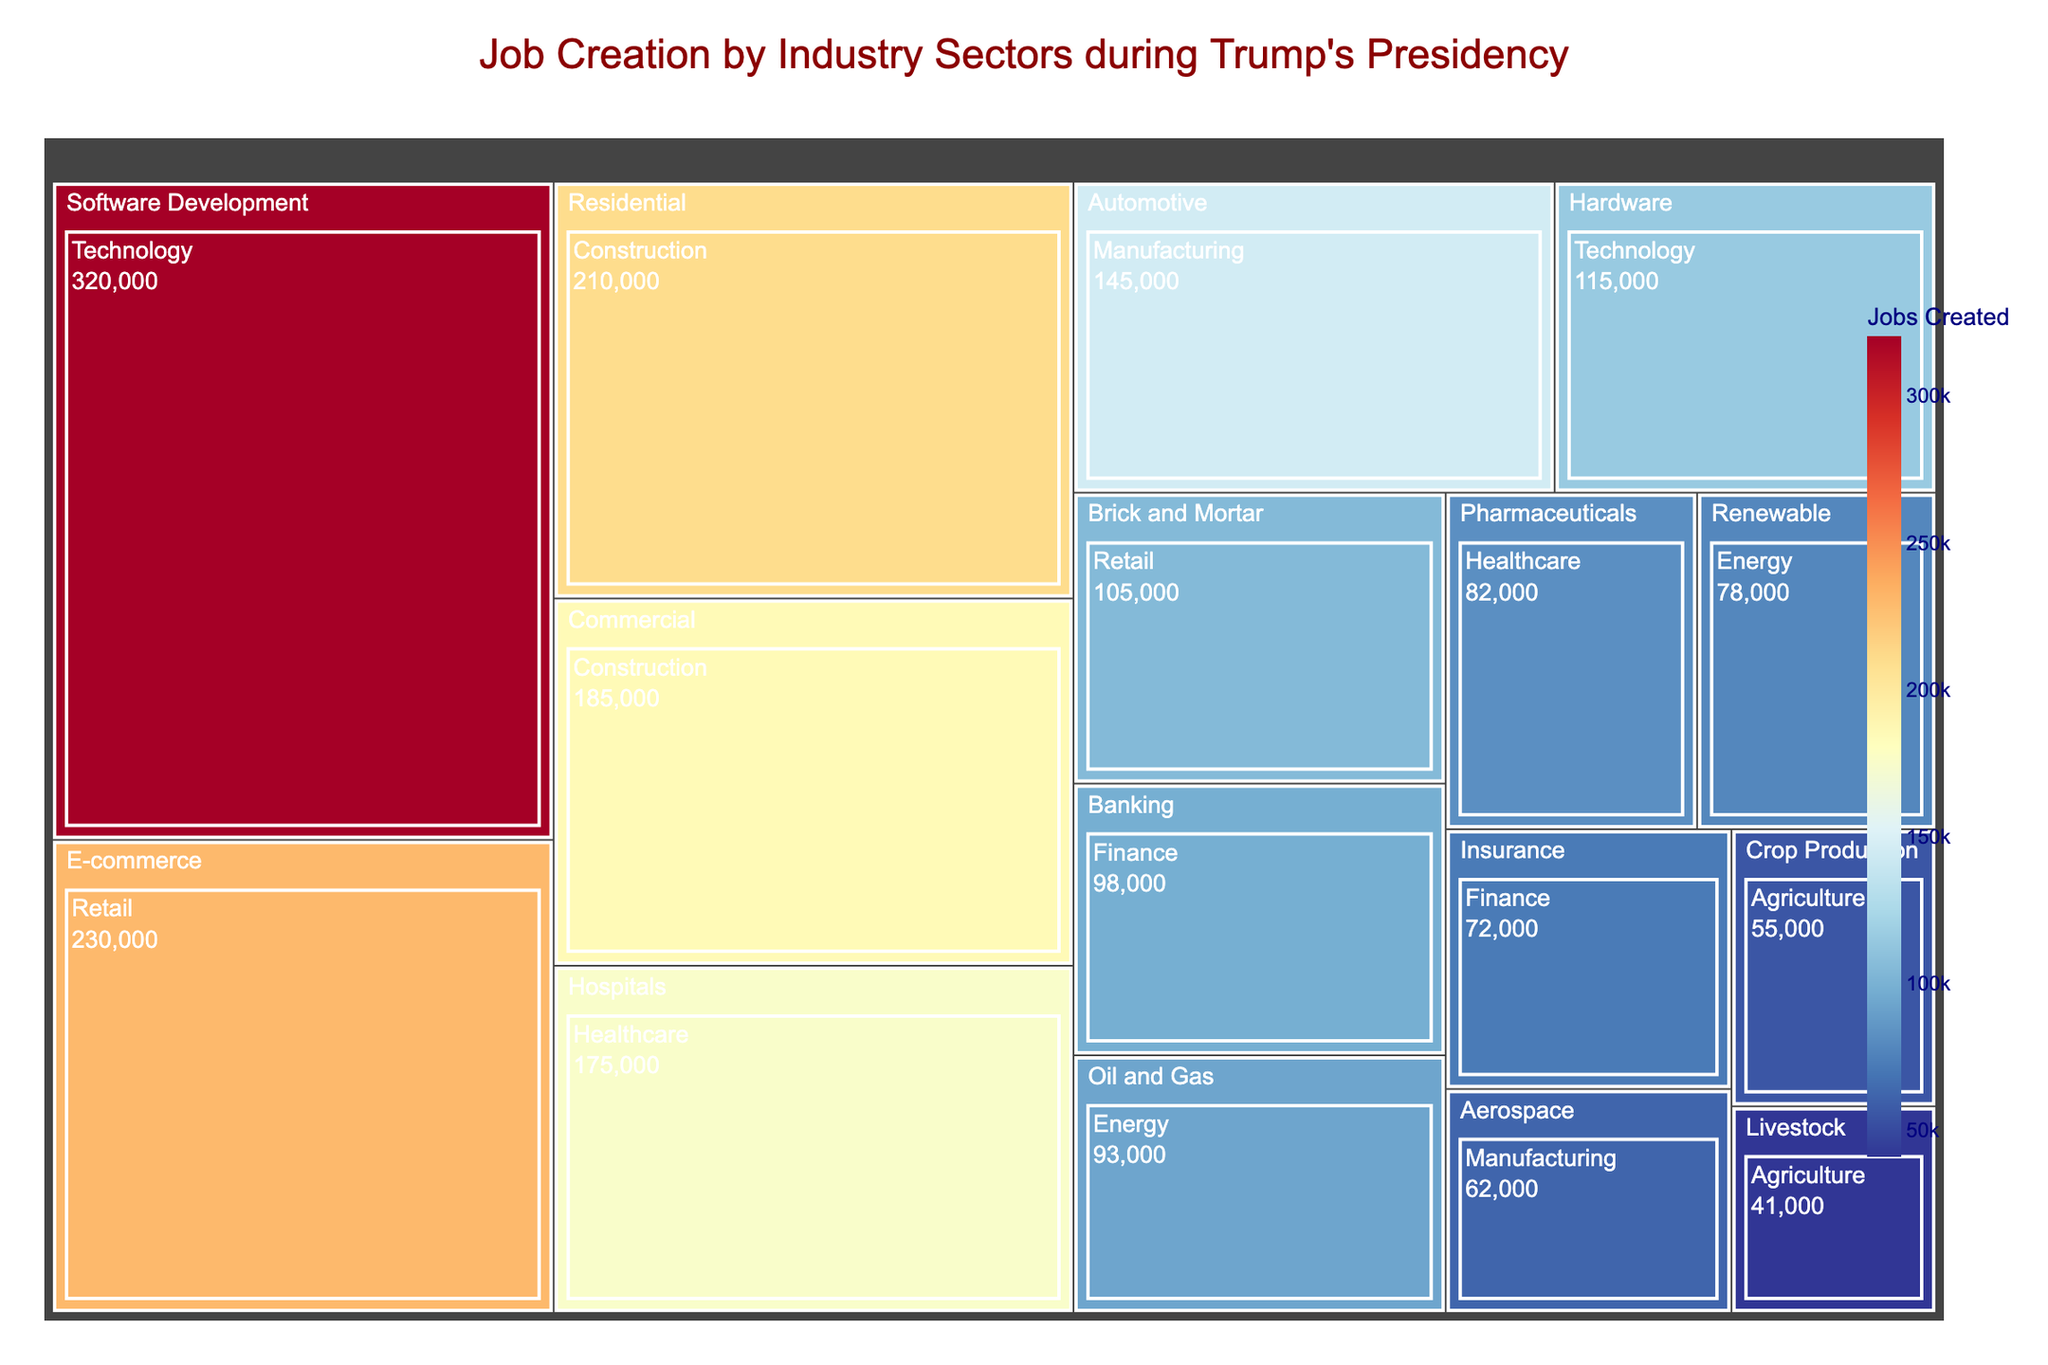Which sector created the most jobs? Look at the treemap and identify the sector with the largest block, which should have the highest labeled value.
Answer: Technology What is the difference in jobs created between the Residential Construction and Commercial Construction industries? Find the jobs created for each industry: Residential Construction (210,000) and Commercial Construction (185,000). Subtract the smaller value from the larger one (210,000 - 185,000).
Answer: 25,000 Which industry within the Technology sector created more jobs: Software Development or Hardware? Look at the treemap blocks within the Technology sector. Identify the blocks for Software Development and Hardware, and compare their job creation values (320,000 for Software Development and 115,000 for Hardware).
Answer: Software Development What is the total number of jobs created in the Manufacturing sector? Locate the blocks under the Manufacturing sector (Automotive and Aerospace). Add their job creation values (145,000 + 62,000).
Answer: 207,000 Which sector created more jobs: Healthcare or Finance? Find the job creation values for both sectors: Healthcare (Hospitals and Pharmaceuticals) and Finance (Banking and Insurance). Sum the values for each sector (175,000 + 82,000 for Healthcare and 98,000 + 72,000 for Finance), and compare the totals.
Answer: Healthcare What is the smallest number of jobs created by any industry in the data? Identify the block with the smallest labeled value in the treemap.
Answer: Livestock (41,000) How many jobs were created in the Retail sector? Find the blocks under Retail (E-commerce and Brick and Mortar) and sum their values (230,000 for E-commerce and 105,000 for Brick and Mortar).
Answer: 335,000 Is the number of jobs created in the Renewable Energy industry greater than those in the Oil and Gas industry? Compare the job creation values for Renewable Energy (78,000) and Oil and Gas (93,000).
Answer: No What is the average number of jobs created by industries within the Energy sector? Calculate the average by summing the job creation values within Energy (Oil and Gas: 93,000 and Renewable: 78,000) and then dividing by the number of industries (2).
Answer: 85,500 Which three industries created the most jobs? Identify and list the three blocks with the highest job creation values from the treemap (Software Development, E-commerce, Residential Construction).
Answer: Software Development, E-commerce, Residential Construction 